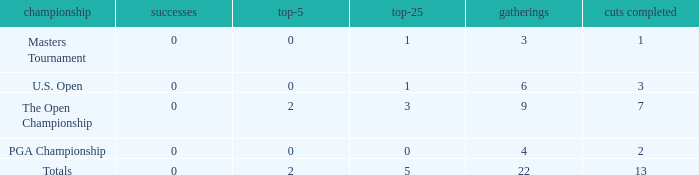What is the fewest wins for Thomas in events he had entered exactly 9 times? 0.0. 